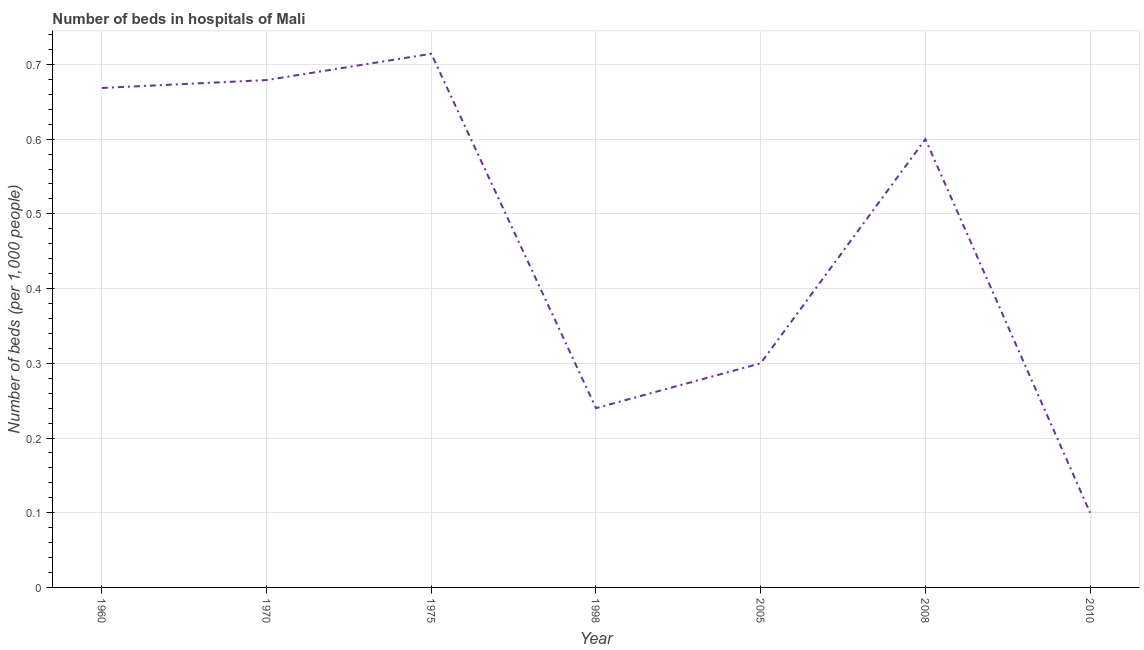What is the number of hospital beds in 2010?
Your response must be concise. 0.1. Across all years, what is the maximum number of hospital beds?
Your answer should be compact. 0.71. Across all years, what is the minimum number of hospital beds?
Ensure brevity in your answer.  0.1. In which year was the number of hospital beds maximum?
Ensure brevity in your answer.  1975. What is the sum of the number of hospital beds?
Ensure brevity in your answer.  3.3. What is the difference between the number of hospital beds in 1975 and 2010?
Keep it short and to the point. 0.61. What is the average number of hospital beds per year?
Provide a short and direct response. 0.47. What is the median number of hospital beds?
Your answer should be compact. 0.6. In how many years, is the number of hospital beds greater than 0.02 %?
Your answer should be very brief. 7. What is the ratio of the number of hospital beds in 1975 to that in 2010?
Your response must be concise. 7.14. Is the number of hospital beds in 1998 less than that in 2008?
Provide a succinct answer. Yes. Is the difference between the number of hospital beds in 1998 and 2005 greater than the difference between any two years?
Offer a terse response. No. What is the difference between the highest and the second highest number of hospital beds?
Make the answer very short. 0.04. Is the sum of the number of hospital beds in 2008 and 2010 greater than the maximum number of hospital beds across all years?
Ensure brevity in your answer.  No. What is the difference between the highest and the lowest number of hospital beds?
Make the answer very short. 0.61. How many lines are there?
Give a very brief answer. 1. Are the values on the major ticks of Y-axis written in scientific E-notation?
Your answer should be compact. No. What is the title of the graph?
Provide a succinct answer. Number of beds in hospitals of Mali. What is the label or title of the X-axis?
Make the answer very short. Year. What is the label or title of the Y-axis?
Ensure brevity in your answer.  Number of beds (per 1,0 people). What is the Number of beds (per 1,000 people) of 1960?
Keep it short and to the point. 0.67. What is the Number of beds (per 1,000 people) of 1970?
Your answer should be very brief. 0.68. What is the Number of beds (per 1,000 people) in 1975?
Offer a terse response. 0.71. What is the Number of beds (per 1,000 people) in 1998?
Offer a terse response. 0.24. What is the Number of beds (per 1,000 people) of 2005?
Your answer should be very brief. 0.3. What is the difference between the Number of beds (per 1,000 people) in 1960 and 1970?
Offer a very short reply. -0.01. What is the difference between the Number of beds (per 1,000 people) in 1960 and 1975?
Ensure brevity in your answer.  -0.05. What is the difference between the Number of beds (per 1,000 people) in 1960 and 1998?
Keep it short and to the point. 0.43. What is the difference between the Number of beds (per 1,000 people) in 1960 and 2005?
Your response must be concise. 0.37. What is the difference between the Number of beds (per 1,000 people) in 1960 and 2008?
Offer a very short reply. 0.07. What is the difference between the Number of beds (per 1,000 people) in 1960 and 2010?
Ensure brevity in your answer.  0.57. What is the difference between the Number of beds (per 1,000 people) in 1970 and 1975?
Your response must be concise. -0.04. What is the difference between the Number of beds (per 1,000 people) in 1970 and 1998?
Your answer should be compact. 0.44. What is the difference between the Number of beds (per 1,000 people) in 1970 and 2005?
Provide a short and direct response. 0.38. What is the difference between the Number of beds (per 1,000 people) in 1970 and 2008?
Provide a short and direct response. 0.08. What is the difference between the Number of beds (per 1,000 people) in 1970 and 2010?
Your response must be concise. 0.58. What is the difference between the Number of beds (per 1,000 people) in 1975 and 1998?
Make the answer very short. 0.47. What is the difference between the Number of beds (per 1,000 people) in 1975 and 2005?
Your answer should be very brief. 0.41. What is the difference between the Number of beds (per 1,000 people) in 1975 and 2008?
Keep it short and to the point. 0.11. What is the difference between the Number of beds (per 1,000 people) in 1975 and 2010?
Provide a short and direct response. 0.61. What is the difference between the Number of beds (per 1,000 people) in 1998 and 2005?
Your response must be concise. -0.06. What is the difference between the Number of beds (per 1,000 people) in 1998 and 2008?
Your response must be concise. -0.36. What is the difference between the Number of beds (per 1,000 people) in 1998 and 2010?
Provide a short and direct response. 0.14. What is the ratio of the Number of beds (per 1,000 people) in 1960 to that in 1975?
Provide a short and direct response. 0.94. What is the ratio of the Number of beds (per 1,000 people) in 1960 to that in 1998?
Keep it short and to the point. 2.79. What is the ratio of the Number of beds (per 1,000 people) in 1960 to that in 2005?
Provide a short and direct response. 2.23. What is the ratio of the Number of beds (per 1,000 people) in 1960 to that in 2008?
Your answer should be compact. 1.11. What is the ratio of the Number of beds (per 1,000 people) in 1960 to that in 2010?
Your response must be concise. 6.68. What is the ratio of the Number of beds (per 1,000 people) in 1970 to that in 1975?
Provide a short and direct response. 0.95. What is the ratio of the Number of beds (per 1,000 people) in 1970 to that in 1998?
Give a very brief answer. 2.83. What is the ratio of the Number of beds (per 1,000 people) in 1970 to that in 2005?
Your answer should be compact. 2.26. What is the ratio of the Number of beds (per 1,000 people) in 1970 to that in 2008?
Provide a succinct answer. 1.13. What is the ratio of the Number of beds (per 1,000 people) in 1970 to that in 2010?
Ensure brevity in your answer.  6.79. What is the ratio of the Number of beds (per 1,000 people) in 1975 to that in 1998?
Keep it short and to the point. 2.98. What is the ratio of the Number of beds (per 1,000 people) in 1975 to that in 2005?
Offer a terse response. 2.38. What is the ratio of the Number of beds (per 1,000 people) in 1975 to that in 2008?
Ensure brevity in your answer.  1.19. What is the ratio of the Number of beds (per 1,000 people) in 1975 to that in 2010?
Give a very brief answer. 7.14. What is the ratio of the Number of beds (per 1,000 people) in 1998 to that in 2005?
Offer a very short reply. 0.8. What is the ratio of the Number of beds (per 1,000 people) in 1998 to that in 2008?
Your response must be concise. 0.4. What is the ratio of the Number of beds (per 1,000 people) in 1998 to that in 2010?
Offer a terse response. 2.4. What is the ratio of the Number of beds (per 1,000 people) in 2005 to that in 2010?
Provide a short and direct response. 3. What is the ratio of the Number of beds (per 1,000 people) in 2008 to that in 2010?
Your answer should be very brief. 6. 